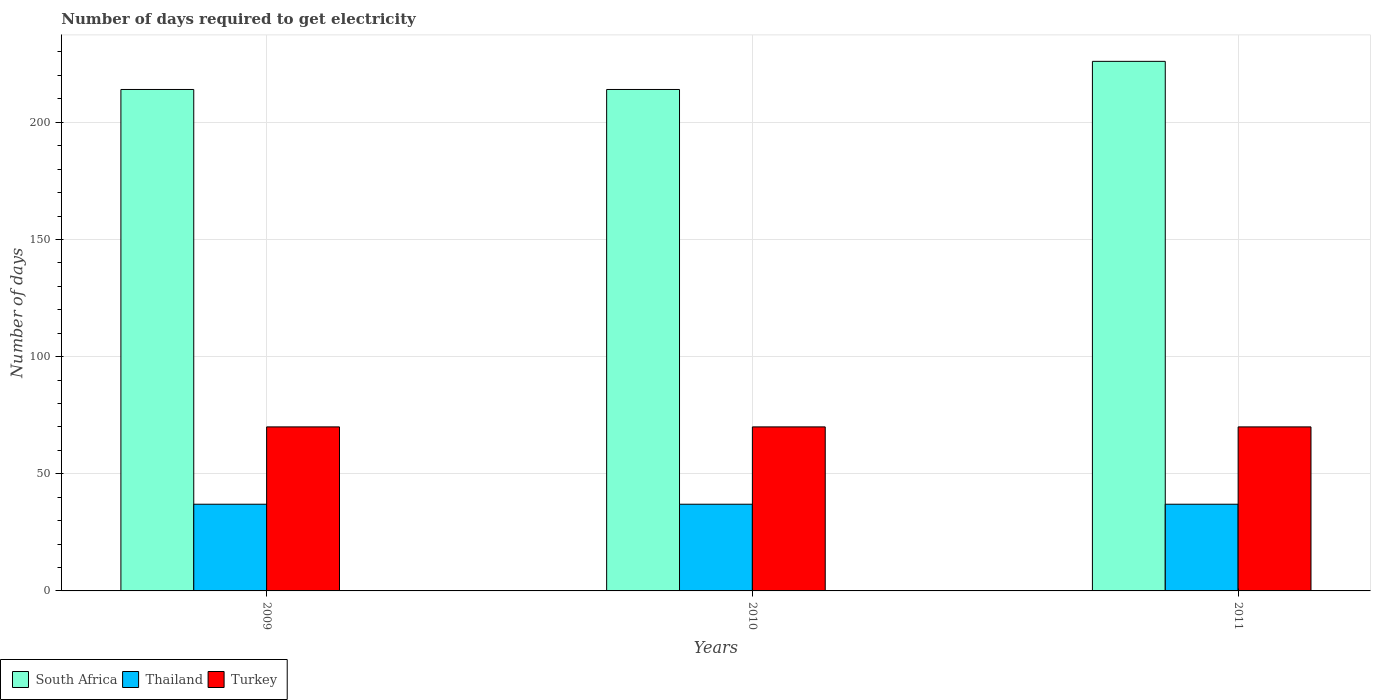Are the number of bars per tick equal to the number of legend labels?
Make the answer very short. Yes. How many bars are there on the 1st tick from the right?
Keep it short and to the point. 3. What is the number of days required to get electricity in in Thailand in 2009?
Make the answer very short. 37. Across all years, what is the maximum number of days required to get electricity in in South Africa?
Offer a very short reply. 226. Across all years, what is the minimum number of days required to get electricity in in South Africa?
Make the answer very short. 214. What is the total number of days required to get electricity in in Thailand in the graph?
Provide a short and direct response. 111. What is the difference between the number of days required to get electricity in in South Africa in 2010 and that in 2011?
Offer a terse response. -12. What is the difference between the number of days required to get electricity in in South Africa in 2011 and the number of days required to get electricity in in Turkey in 2009?
Keep it short and to the point. 156. In the year 2009, what is the difference between the number of days required to get electricity in in Turkey and number of days required to get electricity in in South Africa?
Keep it short and to the point. -144. In how many years, is the number of days required to get electricity in in South Africa greater than 60 days?
Offer a very short reply. 3. What is the difference between the highest and the lowest number of days required to get electricity in in Thailand?
Offer a very short reply. 0. In how many years, is the number of days required to get electricity in in South Africa greater than the average number of days required to get electricity in in South Africa taken over all years?
Provide a short and direct response. 1. What does the 2nd bar from the left in 2009 represents?
Give a very brief answer. Thailand. What does the 3rd bar from the right in 2010 represents?
Your response must be concise. South Africa. Is it the case that in every year, the sum of the number of days required to get electricity in in South Africa and number of days required to get electricity in in Turkey is greater than the number of days required to get electricity in in Thailand?
Your answer should be very brief. Yes. How many bars are there?
Provide a short and direct response. 9. How many years are there in the graph?
Your response must be concise. 3. What is the difference between two consecutive major ticks on the Y-axis?
Give a very brief answer. 50. Does the graph contain grids?
Ensure brevity in your answer.  Yes. How many legend labels are there?
Your response must be concise. 3. How are the legend labels stacked?
Provide a succinct answer. Horizontal. What is the title of the graph?
Ensure brevity in your answer.  Number of days required to get electricity. Does "Eritrea" appear as one of the legend labels in the graph?
Make the answer very short. No. What is the label or title of the X-axis?
Provide a succinct answer. Years. What is the label or title of the Y-axis?
Your answer should be compact. Number of days. What is the Number of days in South Africa in 2009?
Your response must be concise. 214. What is the Number of days of Turkey in 2009?
Your answer should be very brief. 70. What is the Number of days in South Africa in 2010?
Your answer should be compact. 214. What is the Number of days in South Africa in 2011?
Your answer should be compact. 226. Across all years, what is the maximum Number of days of South Africa?
Your response must be concise. 226. Across all years, what is the maximum Number of days of Thailand?
Your answer should be very brief. 37. Across all years, what is the maximum Number of days in Turkey?
Your answer should be very brief. 70. Across all years, what is the minimum Number of days of South Africa?
Your answer should be compact. 214. What is the total Number of days in South Africa in the graph?
Keep it short and to the point. 654. What is the total Number of days in Thailand in the graph?
Offer a very short reply. 111. What is the total Number of days in Turkey in the graph?
Provide a succinct answer. 210. What is the difference between the Number of days in Turkey in 2009 and that in 2010?
Offer a terse response. 0. What is the difference between the Number of days in South Africa in 2010 and that in 2011?
Your answer should be compact. -12. What is the difference between the Number of days in Thailand in 2010 and that in 2011?
Your answer should be very brief. 0. What is the difference between the Number of days of South Africa in 2009 and the Number of days of Thailand in 2010?
Provide a succinct answer. 177. What is the difference between the Number of days of South Africa in 2009 and the Number of days of Turkey in 2010?
Your answer should be compact. 144. What is the difference between the Number of days in Thailand in 2009 and the Number of days in Turkey in 2010?
Make the answer very short. -33. What is the difference between the Number of days in South Africa in 2009 and the Number of days in Thailand in 2011?
Keep it short and to the point. 177. What is the difference between the Number of days in South Africa in 2009 and the Number of days in Turkey in 2011?
Keep it short and to the point. 144. What is the difference between the Number of days in Thailand in 2009 and the Number of days in Turkey in 2011?
Make the answer very short. -33. What is the difference between the Number of days of South Africa in 2010 and the Number of days of Thailand in 2011?
Offer a very short reply. 177. What is the difference between the Number of days in South Africa in 2010 and the Number of days in Turkey in 2011?
Your answer should be compact. 144. What is the difference between the Number of days in Thailand in 2010 and the Number of days in Turkey in 2011?
Your answer should be compact. -33. What is the average Number of days of South Africa per year?
Your answer should be compact. 218. What is the average Number of days in Turkey per year?
Your answer should be very brief. 70. In the year 2009, what is the difference between the Number of days in South Africa and Number of days in Thailand?
Your response must be concise. 177. In the year 2009, what is the difference between the Number of days in South Africa and Number of days in Turkey?
Your response must be concise. 144. In the year 2009, what is the difference between the Number of days of Thailand and Number of days of Turkey?
Make the answer very short. -33. In the year 2010, what is the difference between the Number of days in South Africa and Number of days in Thailand?
Provide a succinct answer. 177. In the year 2010, what is the difference between the Number of days in South Africa and Number of days in Turkey?
Provide a short and direct response. 144. In the year 2010, what is the difference between the Number of days of Thailand and Number of days of Turkey?
Your answer should be compact. -33. In the year 2011, what is the difference between the Number of days of South Africa and Number of days of Thailand?
Make the answer very short. 189. In the year 2011, what is the difference between the Number of days of South Africa and Number of days of Turkey?
Give a very brief answer. 156. In the year 2011, what is the difference between the Number of days of Thailand and Number of days of Turkey?
Make the answer very short. -33. What is the ratio of the Number of days in South Africa in 2009 to that in 2010?
Give a very brief answer. 1. What is the ratio of the Number of days in Thailand in 2009 to that in 2010?
Ensure brevity in your answer.  1. What is the ratio of the Number of days in South Africa in 2009 to that in 2011?
Provide a short and direct response. 0.95. What is the ratio of the Number of days of Thailand in 2009 to that in 2011?
Make the answer very short. 1. What is the ratio of the Number of days of Turkey in 2009 to that in 2011?
Provide a succinct answer. 1. What is the ratio of the Number of days of South Africa in 2010 to that in 2011?
Your answer should be very brief. 0.95. What is the ratio of the Number of days in Turkey in 2010 to that in 2011?
Make the answer very short. 1. What is the difference between the highest and the second highest Number of days in South Africa?
Make the answer very short. 12. What is the difference between the highest and the second highest Number of days of Turkey?
Offer a terse response. 0. What is the difference between the highest and the lowest Number of days of South Africa?
Offer a terse response. 12. 